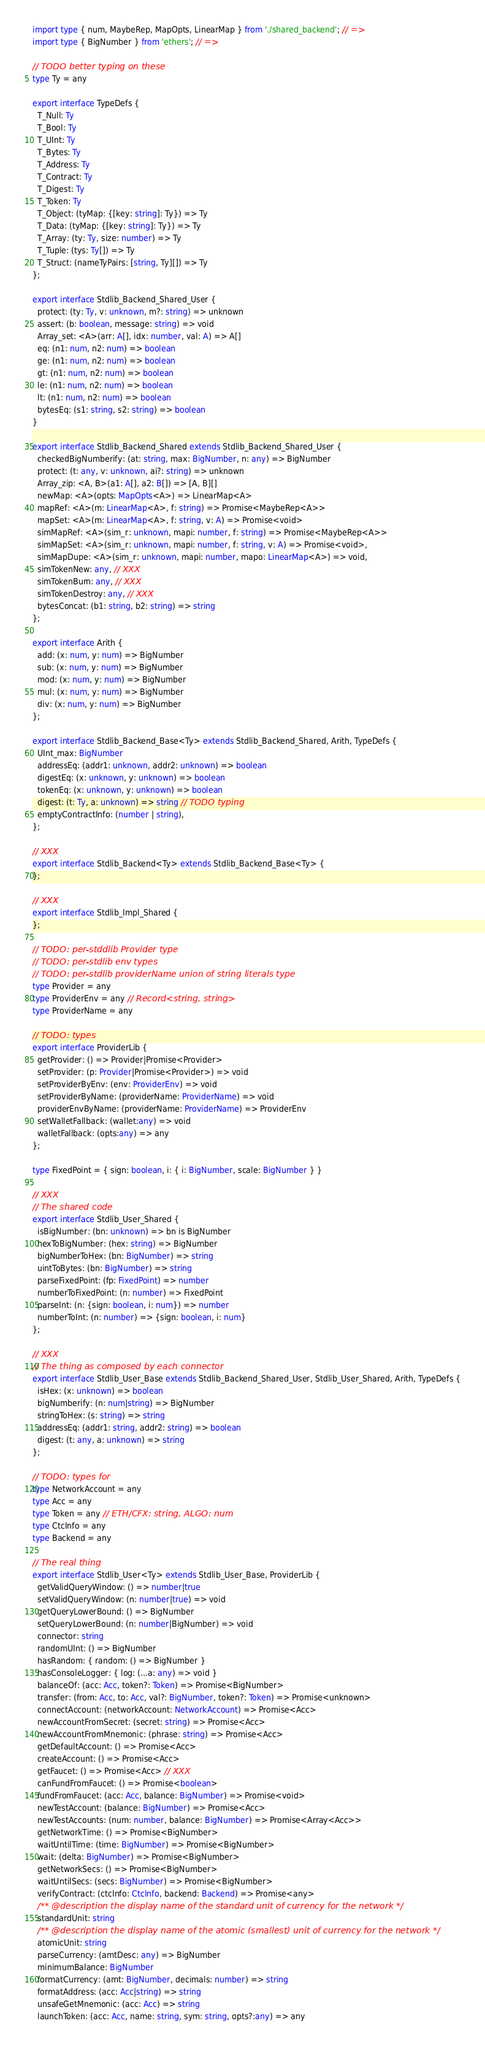<code> <loc_0><loc_0><loc_500><loc_500><_TypeScript_>import type { num, MaybeRep, MapOpts, LinearMap } from './shared_backend'; // =>
import type { BigNumber } from 'ethers'; // =>

// TODO better typing on these
type Ty = any

export interface TypeDefs {
  T_Null: Ty
  T_Bool: Ty
  T_UInt: Ty
  T_Bytes: Ty
  T_Address: Ty
  T_Contract: Ty
  T_Digest: Ty
  T_Token: Ty
  T_Object: (tyMap: {[key: string]: Ty}) => Ty
  T_Data: (tyMap: {[key: string]: Ty}) => Ty
  T_Array: (ty: Ty, size: number) => Ty
  T_Tuple: (tys: Ty[]) => Ty
  T_Struct: (nameTyPairs: [string, Ty][]) => Ty
};

export interface Stdlib_Backend_Shared_User {
  protect: (ty: Ty, v: unknown, m?: string) => unknown
  assert: (b: boolean, message: string) => void
  Array_set: <A>(arr: A[], idx: number, val: A) => A[]
  eq: (n1: num, n2: num) => boolean
  ge: (n1: num, n2: num) => boolean
  gt: (n1: num, n2: num) => boolean
  le: (n1: num, n2: num) => boolean
  lt: (n1: num, n2: num) => boolean
  bytesEq: (s1: string, s2: string) => boolean
}

export interface Stdlib_Backend_Shared extends Stdlib_Backend_Shared_User {
  checkedBigNumberify: (at: string, max: BigNumber, n: any) => BigNumber
  protect: (t: any, v: unknown, ai?: string) => unknown
  Array_zip: <A, B>(a1: A[], a2: B[]) => [A, B][]
  newMap: <A>(opts: MapOpts<A>) => LinearMap<A>
  mapRef: <A>(m: LinearMap<A>, f: string) => Promise<MaybeRep<A>>
  mapSet: <A>(m: LinearMap<A>, f: string, v: A) => Promise<void>
  simMapRef: <A>(sim_r: unknown, mapi: number, f: string) => Promise<MaybeRep<A>>
  simMapSet: <A>(sim_r: unknown, mapi: number, f: string, v: A) => Promise<void>,
  simMapDupe: <A>(sim_r: unknown, mapi: number, mapo: LinearMap<A>) => void,
  simTokenNew: any, // XXX
  simTokenBurn: any, // XXX
  simTokenDestroy: any, // XXX
  bytesConcat: (b1: string, b2: string) => string
};

export interface Arith {
  add: (x: num, y: num) => BigNumber
  sub: (x: num, y: num) => BigNumber
  mod: (x: num, y: num) => BigNumber
  mul: (x: num, y: num) => BigNumber
  div: (x: num, y: num) => BigNumber
};

export interface Stdlib_Backend_Base<Ty> extends Stdlib_Backend_Shared, Arith, TypeDefs {
  UInt_max: BigNumber
  addressEq: (addr1: unknown, addr2: unknown) => boolean
  digestEq: (x: unknown, y: unknown) => boolean
  tokenEq: (x: unknown, y: unknown) => boolean
  digest: (t: Ty, a: unknown) => string // TODO typing
  emptyContractInfo: (number | string),
};

// XXX
export interface Stdlib_Backend<Ty> extends Stdlib_Backend_Base<Ty> {
};

// XXX
export interface Stdlib_Impl_Shared {
};

// TODO: per-stddlib Provider type
// TODO: per-stdlib env types
// TODO: per-stdlib providerName union of string literals type
type Provider = any
type ProviderEnv = any // Record<string, string>
type ProviderName = any

// TODO: types
export interface ProviderLib {
  getProvider: () => Provider|Promise<Provider>
  setProvider: (p: Provider|Promise<Provider>) => void
  setProviderByEnv: (env: ProviderEnv) => void
  setProviderByName: (providerName: ProviderName) => void
  providerEnvByName: (providerName: ProviderName) => ProviderEnv
  setWalletFallback: (wallet:any) => void
  walletFallback: (opts:any) => any
};

type FixedPoint = { sign: boolean, i: { i: BigNumber, scale: BigNumber } }

// XXX
// The shared code
export interface Stdlib_User_Shared {
  isBigNumber: (bn: unknown) => bn is BigNumber
  hexToBigNumber: (hex: string) => BigNumber
  bigNumberToHex: (bn: BigNumber) => string
  uintToBytes: (bn: BigNumber) => string
  parseFixedPoint: (fp: FixedPoint) => number
  numberToFixedPoint: (n: number) => FixedPoint
  parseInt: (n: {sign: boolean, i: num}) => number
  numberToInt: (n: number) => {sign: boolean, i: num}
};

// XXX
// The thing as composed by each connector
export interface Stdlib_User_Base extends Stdlib_Backend_Shared_User, Stdlib_User_Shared, Arith, TypeDefs {
  isHex: (x: unknown) => boolean
  bigNumberify: (n: num|string) => BigNumber
  stringToHex: (s: string) => string
  addressEq: (addr1: string, addr2: string) => boolean
  digest: (t: any, a: unknown) => string
};

// TODO: types for
type NetworkAccount = any
type Acc = any
type Token = any // ETH/CFX: string, ALGO: num
type CtcInfo = any
type Backend = any

// The real thing
export interface Stdlib_User<Ty> extends Stdlib_User_Base, ProviderLib {
  getValidQueryWindow: () => number|true
  setValidQueryWindow: (n: number|true) => void
  getQueryLowerBound: () => BigNumber
  setQueryLowerBound: (n: number|BigNumber) => void
  connector: string
  randomUInt: () => BigNumber
  hasRandom: { random: () => BigNumber }
  hasConsoleLogger: { log: (...a: any) => void }
  balanceOf: (acc: Acc, token?: Token) => Promise<BigNumber>
  transfer: (from: Acc, to: Acc, val?: BigNumber, token?: Token) => Promise<unknown>
  connectAccount: (networkAccount: NetworkAccount) => Promise<Acc>
  newAccountFromSecret: (secret: string) => Promise<Acc>
  newAccountFromMnemonic: (phrase: string) => Promise<Acc>
  getDefaultAccount: () => Promise<Acc>
  createAccount: () => Promise<Acc>
  getFaucet: () => Promise<Acc> // XXX
  canFundFromFaucet: () => Promise<boolean>
  fundFromFaucet: (acc: Acc, balance: BigNumber) => Promise<void>
  newTestAccount: (balance: BigNumber) => Promise<Acc>
  newTestAccounts: (num: number, balance: BigNumber) => Promise<Array<Acc>>
  getNetworkTime: () => Promise<BigNumber>
  waitUntilTime: (time: BigNumber) => Promise<BigNumber>
  wait: (delta: BigNumber) => Promise<BigNumber>
  getNetworkSecs: () => Promise<BigNumber>
  waitUntilSecs: (secs: BigNumber) => Promise<BigNumber>
  verifyContract: (ctcInfo: CtcInfo, backend: Backend) => Promise<any>
  /** @description the display name of the standard unit of currency for the network */
  standardUnit: string
  /** @description the display name of the atomic (smallest) unit of currency for the network */
  atomicUnit: string
  parseCurrency: (amtDesc: any) => BigNumber
  minimumBalance: BigNumber
  formatCurrency: (amt: BigNumber, decimals: number) => string
  formatAddress: (acc: Acc|string) => string
  unsafeGetMnemonic: (acc: Acc) => string
  launchToken: (acc: Acc, name: string, sym: string, opts?:any) => any</code> 